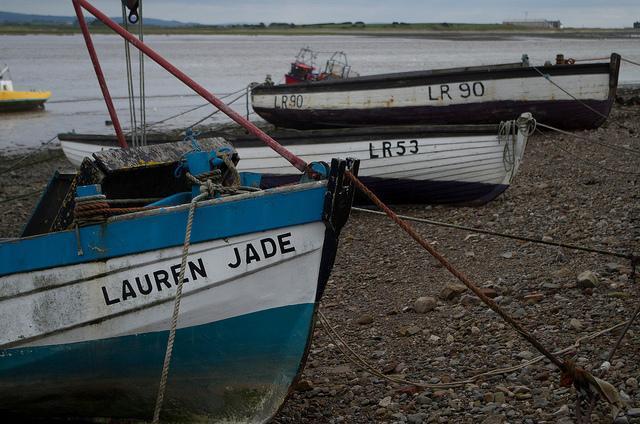How many boats are in the picture?
Give a very brief answer. 3. 